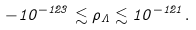Convert formula to latex. <formula><loc_0><loc_0><loc_500><loc_500>- 1 0 ^ { - 1 2 3 } \lesssim \rho _ { \Lambda } \lesssim 1 0 ^ { - 1 2 1 } .</formula> 